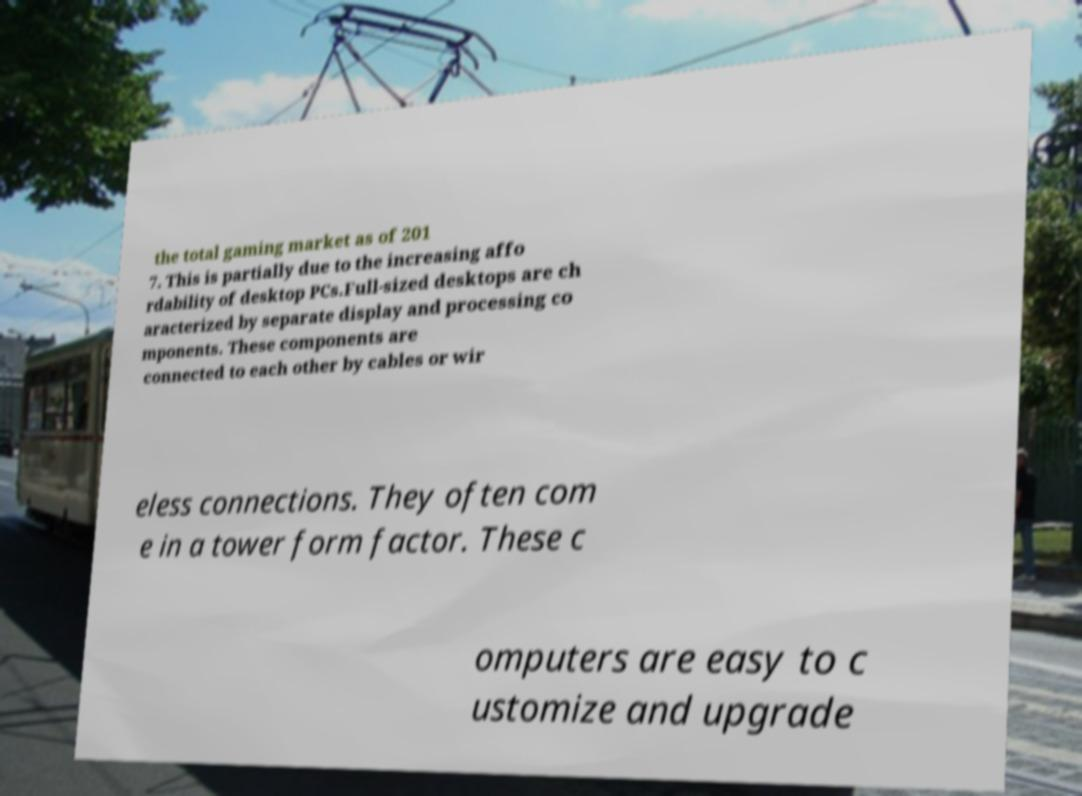Could you extract and type out the text from this image? the total gaming market as of 201 7. This is partially due to the increasing affo rdability of desktop PCs.Full-sized desktops are ch aracterized by separate display and processing co mponents. These components are connected to each other by cables or wir eless connections. They often com e in a tower form factor. These c omputers are easy to c ustomize and upgrade 